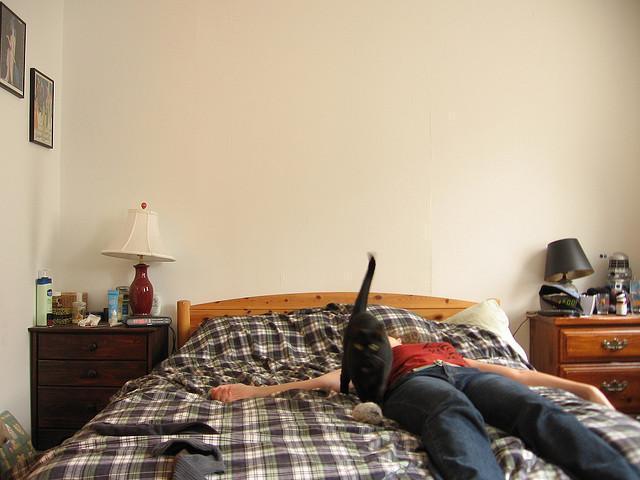How many lamp shades are straight?
Give a very brief answer. 0. 